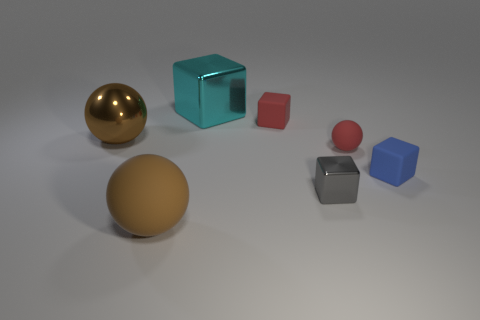The metallic thing that is the same size as the red matte cube is what color?
Your response must be concise. Gray. There is a large rubber thing; is its shape the same as the brown thing behind the small metal thing?
Your response must be concise. Yes. What material is the brown thing that is in front of the rubber ball right of the small thing in front of the small blue matte thing made of?
Your response must be concise. Rubber. What number of tiny things are shiny spheres or blue objects?
Your answer should be compact. 1. What number of other things are there of the same size as the gray metal block?
Give a very brief answer. 3. Is the shape of the matte object that is behind the big brown metallic ball the same as  the big rubber thing?
Keep it short and to the point. No. There is another metal thing that is the same shape as the tiny gray metallic object; what color is it?
Your answer should be very brief. Cyan. Are there any other things that have the same shape as the small metallic thing?
Give a very brief answer. Yes. Is the number of large matte objects that are to the right of the tiny gray metal cube the same as the number of blue objects?
Provide a short and direct response. No. What number of objects are to the right of the red cube and behind the gray thing?
Provide a succinct answer. 2. 